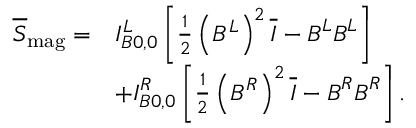<formula> <loc_0><loc_0><loc_500><loc_500>\begin{array} { r l } { \overline { S } _ { m a g } = } & { I _ { B 0 , 0 } ^ { L } \left [ \frac { 1 } { 2 } \left ( B ^ { L } \right ) ^ { 2 } \overline { I } - B ^ { L } B ^ { L } \right ] } \\ & { + I _ { B 0 , 0 } ^ { R } \left [ \frac { 1 } { 2 } \left ( B ^ { R } \right ) ^ { 2 } \overline { I } - B ^ { R } B ^ { R } \right ] . } \end{array}</formula> 